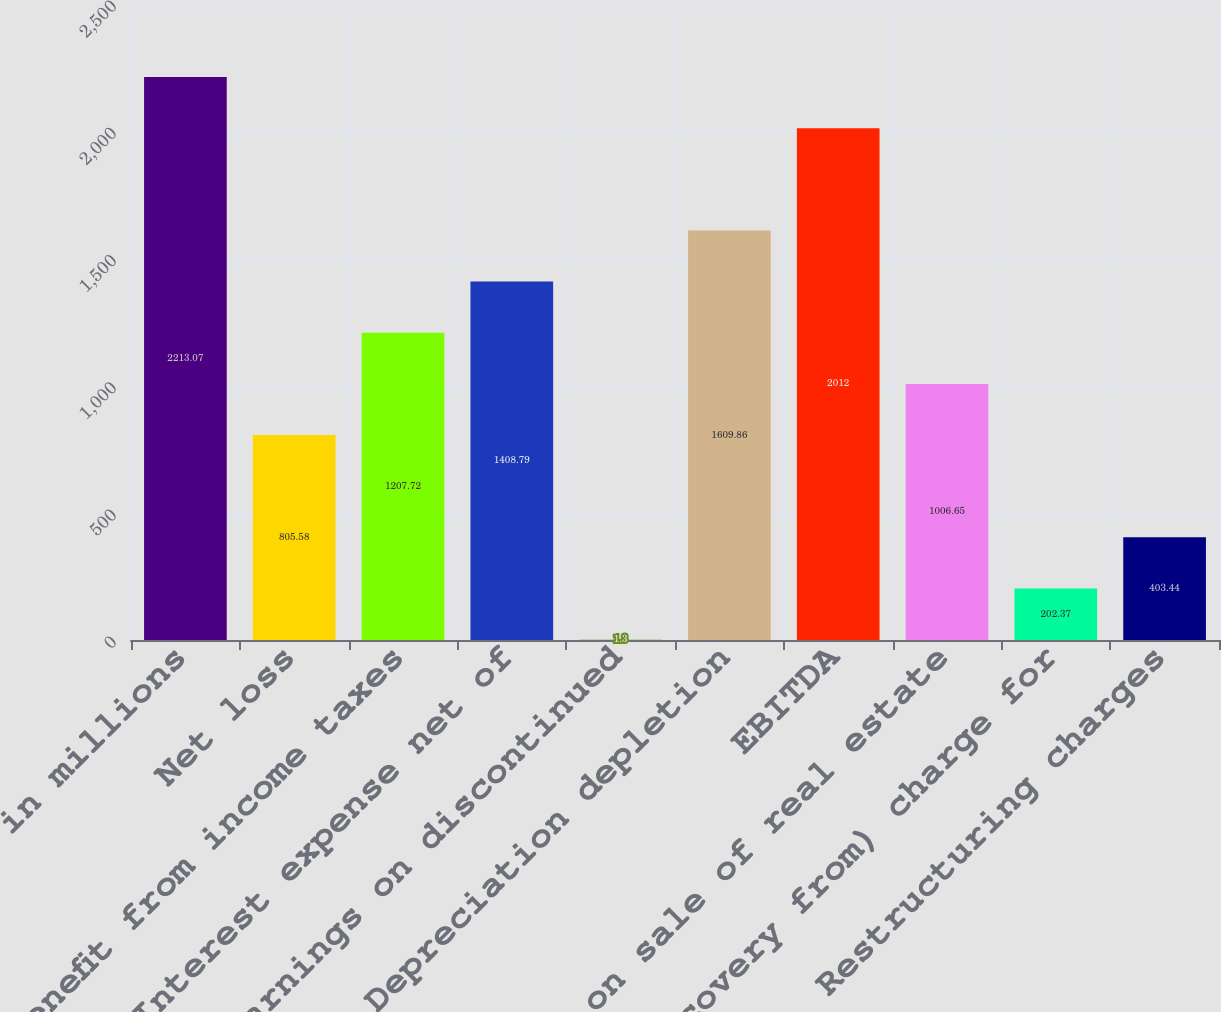Convert chart to OTSL. <chart><loc_0><loc_0><loc_500><loc_500><bar_chart><fcel>in millions<fcel>Net loss<fcel>Benefit from income taxes<fcel>Interest expense net of<fcel>Earnings on discontinued<fcel>Depreciation depletion<fcel>EBITDA<fcel>Gain on sale of real estate<fcel>(Recovery from) charge for<fcel>Restructuring charges<nl><fcel>2213.07<fcel>805.58<fcel>1207.72<fcel>1408.79<fcel>1.3<fcel>1609.86<fcel>2012<fcel>1006.65<fcel>202.37<fcel>403.44<nl></chart> 